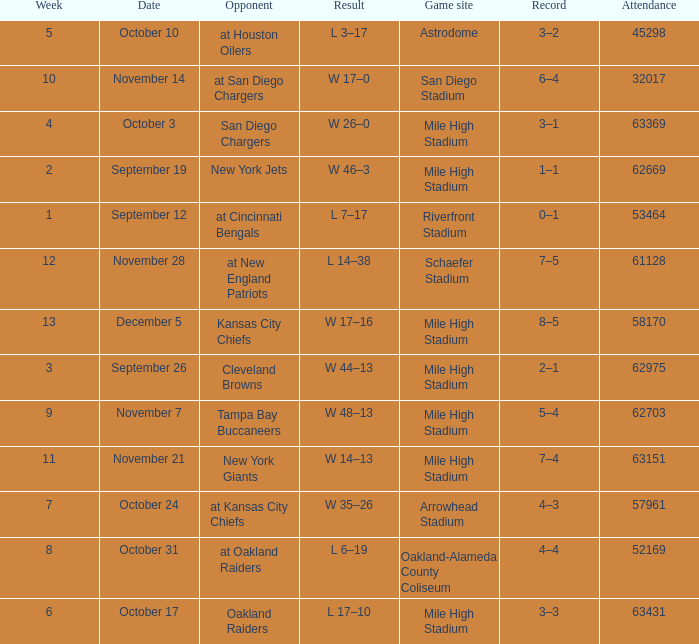What was the week number when the opponent was the New York Jets? 2.0. 